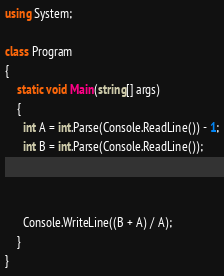Convert code to text. <code><loc_0><loc_0><loc_500><loc_500><_C#_>using System;

class Program
{
    static void Main(string[] args)
    {
      int A = int.Parse(Console.ReadLine()) - 1;
      int B = int.Parse(Console.ReadLine());
      
      
      
      Console.WriteLine((B + A) / A);
    }
}
</code> 